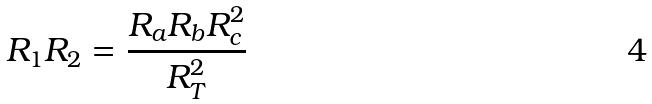<formula> <loc_0><loc_0><loc_500><loc_500>R _ { 1 } R _ { 2 } = \frac { R _ { a } R _ { b } R _ { c } ^ { 2 } } { R _ { T } ^ { 2 } }</formula> 